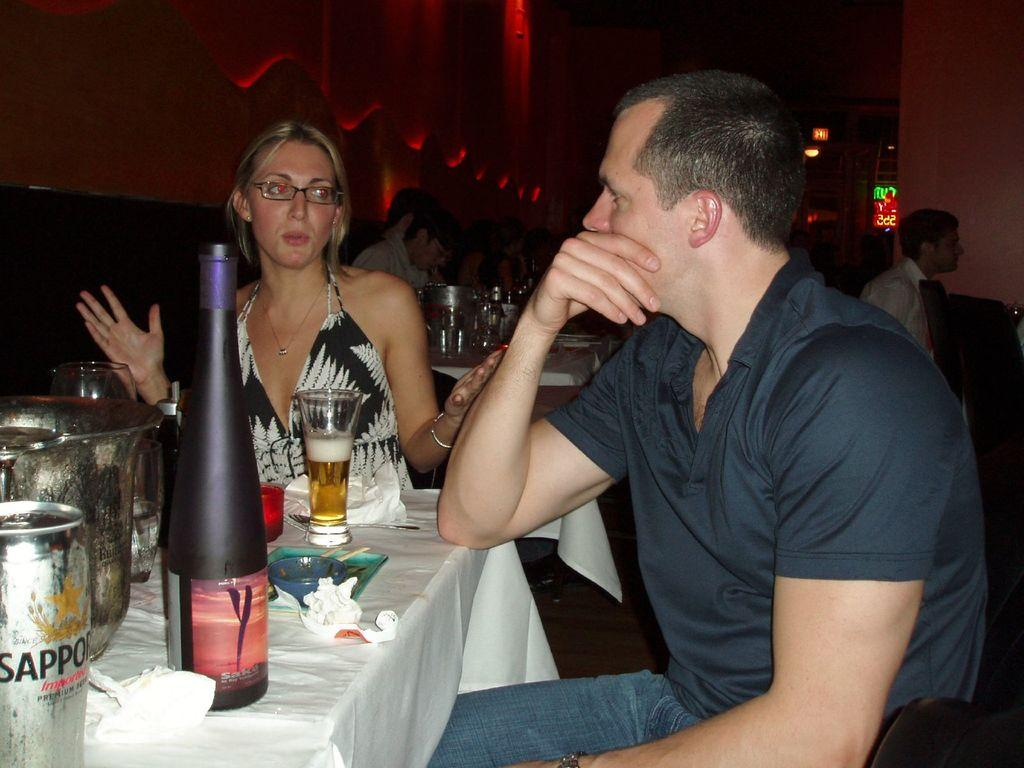<image>
Present a compact description of the photo's key features. A silver can has a brand name on it that starts with the letter S. 